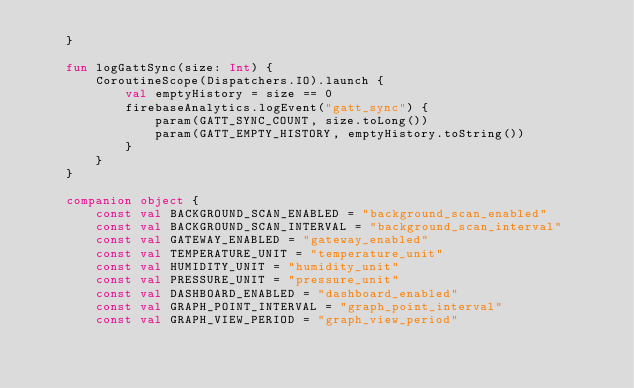<code> <loc_0><loc_0><loc_500><loc_500><_Kotlin_>    }

    fun logGattSync(size: Int) {
        CoroutineScope(Dispatchers.IO).launch {
            val emptyHistory = size == 0
            firebaseAnalytics.logEvent("gatt_sync") {
                param(GATT_SYNC_COUNT, size.toLong())
                param(GATT_EMPTY_HISTORY, emptyHistory.toString())
            }
        }
    }

    companion object {
        const val BACKGROUND_SCAN_ENABLED = "background_scan_enabled"
        const val BACKGROUND_SCAN_INTERVAL = "background_scan_interval"
        const val GATEWAY_ENABLED = "gateway_enabled"
        const val TEMPERATURE_UNIT = "temperature_unit"
        const val HUMIDITY_UNIT = "humidity_unit"
        const val PRESSURE_UNIT = "pressure_unit"
        const val DASHBOARD_ENABLED = "dashboard_enabled"
        const val GRAPH_POINT_INTERVAL = "graph_point_interval"
        const val GRAPH_VIEW_PERIOD = "graph_view_period"</code> 